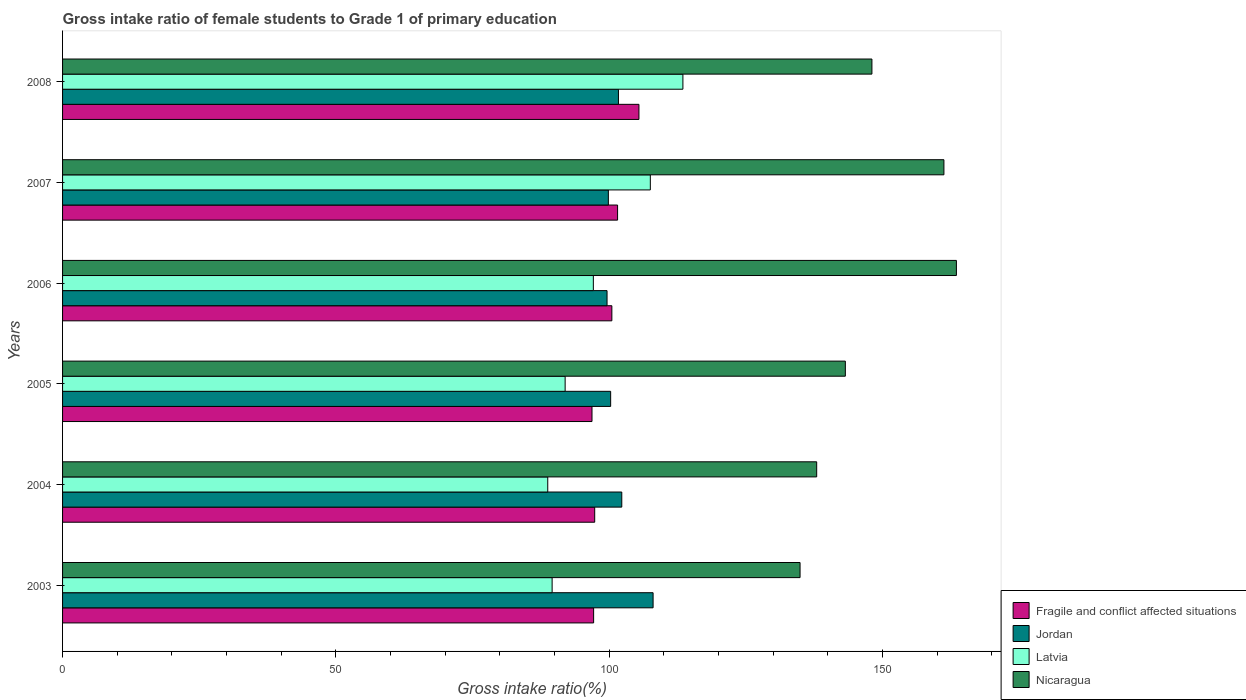How many different coloured bars are there?
Ensure brevity in your answer.  4. How many groups of bars are there?
Your answer should be very brief. 6. Are the number of bars per tick equal to the number of legend labels?
Provide a short and direct response. Yes. Are the number of bars on each tick of the Y-axis equal?
Offer a very short reply. Yes. How many bars are there on the 6th tick from the top?
Provide a succinct answer. 4. What is the gross intake ratio in Jordan in 2004?
Your response must be concise. 102.3. Across all years, what is the maximum gross intake ratio in Jordan?
Keep it short and to the point. 108.03. Across all years, what is the minimum gross intake ratio in Fragile and conflict affected situations?
Ensure brevity in your answer.  96.86. In which year was the gross intake ratio in Latvia maximum?
Offer a very short reply. 2008. In which year was the gross intake ratio in Jordan minimum?
Your response must be concise. 2006. What is the total gross intake ratio in Latvia in the graph?
Provide a short and direct response. 588.38. What is the difference between the gross intake ratio in Jordan in 2005 and that in 2006?
Provide a short and direct response. 0.66. What is the difference between the gross intake ratio in Latvia in 2006 and the gross intake ratio in Fragile and conflict affected situations in 2005?
Offer a terse response. 0.25. What is the average gross intake ratio in Latvia per year?
Make the answer very short. 98.06. In the year 2006, what is the difference between the gross intake ratio in Jordan and gross intake ratio in Fragile and conflict affected situations?
Your answer should be very brief. -0.88. In how many years, is the gross intake ratio in Jordan greater than 130 %?
Your response must be concise. 0. What is the ratio of the gross intake ratio in Latvia in 2006 to that in 2008?
Provide a short and direct response. 0.86. What is the difference between the highest and the second highest gross intake ratio in Jordan?
Ensure brevity in your answer.  5.73. What is the difference between the highest and the lowest gross intake ratio in Nicaragua?
Provide a succinct answer. 28.6. In how many years, is the gross intake ratio in Latvia greater than the average gross intake ratio in Latvia taken over all years?
Make the answer very short. 2. Is the sum of the gross intake ratio in Latvia in 2005 and 2008 greater than the maximum gross intake ratio in Nicaragua across all years?
Provide a short and direct response. Yes. Is it the case that in every year, the sum of the gross intake ratio in Nicaragua and gross intake ratio in Latvia is greater than the sum of gross intake ratio in Fragile and conflict affected situations and gross intake ratio in Jordan?
Offer a very short reply. Yes. What does the 1st bar from the top in 2003 represents?
Offer a terse response. Nicaragua. What does the 1st bar from the bottom in 2008 represents?
Provide a succinct answer. Fragile and conflict affected situations. Is it the case that in every year, the sum of the gross intake ratio in Latvia and gross intake ratio in Fragile and conflict affected situations is greater than the gross intake ratio in Jordan?
Keep it short and to the point. Yes. How many bars are there?
Keep it short and to the point. 24. How many years are there in the graph?
Ensure brevity in your answer.  6. What is the difference between two consecutive major ticks on the X-axis?
Your answer should be very brief. 50. Does the graph contain any zero values?
Give a very brief answer. No. How many legend labels are there?
Your answer should be compact. 4. What is the title of the graph?
Your answer should be very brief. Gross intake ratio of female students to Grade 1 of primary education. What is the label or title of the X-axis?
Offer a terse response. Gross intake ratio(%). What is the label or title of the Y-axis?
Make the answer very short. Years. What is the Gross intake ratio(%) in Fragile and conflict affected situations in 2003?
Offer a terse response. 97.15. What is the Gross intake ratio(%) of Jordan in 2003?
Your answer should be very brief. 108.03. What is the Gross intake ratio(%) in Latvia in 2003?
Provide a short and direct response. 89.56. What is the Gross intake ratio(%) of Nicaragua in 2003?
Offer a terse response. 134.92. What is the Gross intake ratio(%) of Fragile and conflict affected situations in 2004?
Your answer should be very brief. 97.35. What is the Gross intake ratio(%) in Jordan in 2004?
Offer a terse response. 102.3. What is the Gross intake ratio(%) of Latvia in 2004?
Your response must be concise. 88.76. What is the Gross intake ratio(%) of Nicaragua in 2004?
Your response must be concise. 137.96. What is the Gross intake ratio(%) in Fragile and conflict affected situations in 2005?
Your answer should be compact. 96.86. What is the Gross intake ratio(%) of Jordan in 2005?
Give a very brief answer. 100.27. What is the Gross intake ratio(%) in Latvia in 2005?
Your answer should be compact. 91.94. What is the Gross intake ratio(%) of Nicaragua in 2005?
Offer a terse response. 143.2. What is the Gross intake ratio(%) in Fragile and conflict affected situations in 2006?
Make the answer very short. 100.49. What is the Gross intake ratio(%) of Jordan in 2006?
Your answer should be compact. 99.61. What is the Gross intake ratio(%) in Latvia in 2006?
Offer a very short reply. 97.1. What is the Gross intake ratio(%) in Nicaragua in 2006?
Make the answer very short. 163.52. What is the Gross intake ratio(%) of Fragile and conflict affected situations in 2007?
Provide a short and direct response. 101.53. What is the Gross intake ratio(%) in Jordan in 2007?
Your response must be concise. 99.85. What is the Gross intake ratio(%) of Latvia in 2007?
Provide a short and direct response. 107.53. What is the Gross intake ratio(%) of Nicaragua in 2007?
Provide a succinct answer. 161.24. What is the Gross intake ratio(%) in Fragile and conflict affected situations in 2008?
Offer a terse response. 105.44. What is the Gross intake ratio(%) in Jordan in 2008?
Provide a short and direct response. 101.69. What is the Gross intake ratio(%) of Latvia in 2008?
Offer a very short reply. 113.48. What is the Gross intake ratio(%) in Nicaragua in 2008?
Your answer should be compact. 148.06. Across all years, what is the maximum Gross intake ratio(%) in Fragile and conflict affected situations?
Your response must be concise. 105.44. Across all years, what is the maximum Gross intake ratio(%) of Jordan?
Keep it short and to the point. 108.03. Across all years, what is the maximum Gross intake ratio(%) of Latvia?
Your answer should be compact. 113.48. Across all years, what is the maximum Gross intake ratio(%) of Nicaragua?
Offer a terse response. 163.52. Across all years, what is the minimum Gross intake ratio(%) in Fragile and conflict affected situations?
Keep it short and to the point. 96.86. Across all years, what is the minimum Gross intake ratio(%) of Jordan?
Give a very brief answer. 99.61. Across all years, what is the minimum Gross intake ratio(%) in Latvia?
Ensure brevity in your answer.  88.76. Across all years, what is the minimum Gross intake ratio(%) of Nicaragua?
Give a very brief answer. 134.92. What is the total Gross intake ratio(%) of Fragile and conflict affected situations in the graph?
Offer a terse response. 598.82. What is the total Gross intake ratio(%) in Jordan in the graph?
Offer a terse response. 611.75. What is the total Gross intake ratio(%) of Latvia in the graph?
Your answer should be very brief. 588.38. What is the total Gross intake ratio(%) in Nicaragua in the graph?
Give a very brief answer. 888.9. What is the difference between the Gross intake ratio(%) in Fragile and conflict affected situations in 2003 and that in 2004?
Make the answer very short. -0.2. What is the difference between the Gross intake ratio(%) of Jordan in 2003 and that in 2004?
Provide a succinct answer. 5.73. What is the difference between the Gross intake ratio(%) in Latvia in 2003 and that in 2004?
Your response must be concise. 0.8. What is the difference between the Gross intake ratio(%) in Nicaragua in 2003 and that in 2004?
Provide a succinct answer. -3.04. What is the difference between the Gross intake ratio(%) in Fragile and conflict affected situations in 2003 and that in 2005?
Keep it short and to the point. 0.3. What is the difference between the Gross intake ratio(%) in Jordan in 2003 and that in 2005?
Offer a very short reply. 7.76. What is the difference between the Gross intake ratio(%) of Latvia in 2003 and that in 2005?
Keep it short and to the point. -2.38. What is the difference between the Gross intake ratio(%) in Nicaragua in 2003 and that in 2005?
Give a very brief answer. -8.28. What is the difference between the Gross intake ratio(%) in Fragile and conflict affected situations in 2003 and that in 2006?
Your answer should be compact. -3.34. What is the difference between the Gross intake ratio(%) of Jordan in 2003 and that in 2006?
Give a very brief answer. 8.42. What is the difference between the Gross intake ratio(%) of Latvia in 2003 and that in 2006?
Offer a terse response. -7.54. What is the difference between the Gross intake ratio(%) of Nicaragua in 2003 and that in 2006?
Give a very brief answer. -28.6. What is the difference between the Gross intake ratio(%) in Fragile and conflict affected situations in 2003 and that in 2007?
Your answer should be compact. -4.38. What is the difference between the Gross intake ratio(%) of Jordan in 2003 and that in 2007?
Offer a very short reply. 8.18. What is the difference between the Gross intake ratio(%) in Latvia in 2003 and that in 2007?
Ensure brevity in your answer.  -17.97. What is the difference between the Gross intake ratio(%) in Nicaragua in 2003 and that in 2007?
Your answer should be compact. -26.32. What is the difference between the Gross intake ratio(%) in Fragile and conflict affected situations in 2003 and that in 2008?
Provide a succinct answer. -8.29. What is the difference between the Gross intake ratio(%) of Jordan in 2003 and that in 2008?
Ensure brevity in your answer.  6.34. What is the difference between the Gross intake ratio(%) of Latvia in 2003 and that in 2008?
Provide a short and direct response. -23.92. What is the difference between the Gross intake ratio(%) of Nicaragua in 2003 and that in 2008?
Offer a terse response. -13.15. What is the difference between the Gross intake ratio(%) of Fragile and conflict affected situations in 2004 and that in 2005?
Provide a succinct answer. 0.49. What is the difference between the Gross intake ratio(%) of Jordan in 2004 and that in 2005?
Provide a succinct answer. 2.03. What is the difference between the Gross intake ratio(%) of Latvia in 2004 and that in 2005?
Your answer should be very brief. -3.18. What is the difference between the Gross intake ratio(%) of Nicaragua in 2004 and that in 2005?
Your answer should be compact. -5.24. What is the difference between the Gross intake ratio(%) of Fragile and conflict affected situations in 2004 and that in 2006?
Keep it short and to the point. -3.14. What is the difference between the Gross intake ratio(%) in Jordan in 2004 and that in 2006?
Your response must be concise. 2.69. What is the difference between the Gross intake ratio(%) in Latvia in 2004 and that in 2006?
Make the answer very short. -8.34. What is the difference between the Gross intake ratio(%) in Nicaragua in 2004 and that in 2006?
Give a very brief answer. -25.56. What is the difference between the Gross intake ratio(%) in Fragile and conflict affected situations in 2004 and that in 2007?
Provide a short and direct response. -4.18. What is the difference between the Gross intake ratio(%) of Jordan in 2004 and that in 2007?
Make the answer very short. 2.45. What is the difference between the Gross intake ratio(%) in Latvia in 2004 and that in 2007?
Keep it short and to the point. -18.77. What is the difference between the Gross intake ratio(%) in Nicaragua in 2004 and that in 2007?
Your answer should be compact. -23.28. What is the difference between the Gross intake ratio(%) in Fragile and conflict affected situations in 2004 and that in 2008?
Give a very brief answer. -8.09. What is the difference between the Gross intake ratio(%) in Jordan in 2004 and that in 2008?
Make the answer very short. 0.61. What is the difference between the Gross intake ratio(%) in Latvia in 2004 and that in 2008?
Your answer should be very brief. -24.72. What is the difference between the Gross intake ratio(%) of Nicaragua in 2004 and that in 2008?
Give a very brief answer. -10.1. What is the difference between the Gross intake ratio(%) in Fragile and conflict affected situations in 2005 and that in 2006?
Give a very brief answer. -3.63. What is the difference between the Gross intake ratio(%) in Jordan in 2005 and that in 2006?
Offer a terse response. 0.66. What is the difference between the Gross intake ratio(%) in Latvia in 2005 and that in 2006?
Provide a succinct answer. -5.16. What is the difference between the Gross intake ratio(%) in Nicaragua in 2005 and that in 2006?
Provide a succinct answer. -20.32. What is the difference between the Gross intake ratio(%) of Fragile and conflict affected situations in 2005 and that in 2007?
Give a very brief answer. -4.68. What is the difference between the Gross intake ratio(%) of Jordan in 2005 and that in 2007?
Your answer should be compact. 0.42. What is the difference between the Gross intake ratio(%) in Latvia in 2005 and that in 2007?
Ensure brevity in your answer.  -15.59. What is the difference between the Gross intake ratio(%) in Nicaragua in 2005 and that in 2007?
Keep it short and to the point. -18.03. What is the difference between the Gross intake ratio(%) of Fragile and conflict affected situations in 2005 and that in 2008?
Ensure brevity in your answer.  -8.59. What is the difference between the Gross intake ratio(%) in Jordan in 2005 and that in 2008?
Ensure brevity in your answer.  -1.43. What is the difference between the Gross intake ratio(%) of Latvia in 2005 and that in 2008?
Offer a terse response. -21.54. What is the difference between the Gross intake ratio(%) in Nicaragua in 2005 and that in 2008?
Keep it short and to the point. -4.86. What is the difference between the Gross intake ratio(%) of Fragile and conflict affected situations in 2006 and that in 2007?
Make the answer very short. -1.04. What is the difference between the Gross intake ratio(%) of Jordan in 2006 and that in 2007?
Provide a short and direct response. -0.24. What is the difference between the Gross intake ratio(%) in Latvia in 2006 and that in 2007?
Your answer should be very brief. -10.42. What is the difference between the Gross intake ratio(%) of Nicaragua in 2006 and that in 2007?
Ensure brevity in your answer.  2.29. What is the difference between the Gross intake ratio(%) of Fragile and conflict affected situations in 2006 and that in 2008?
Give a very brief answer. -4.95. What is the difference between the Gross intake ratio(%) in Jordan in 2006 and that in 2008?
Your answer should be very brief. -2.09. What is the difference between the Gross intake ratio(%) in Latvia in 2006 and that in 2008?
Offer a terse response. -16.38. What is the difference between the Gross intake ratio(%) in Nicaragua in 2006 and that in 2008?
Ensure brevity in your answer.  15.46. What is the difference between the Gross intake ratio(%) in Fragile and conflict affected situations in 2007 and that in 2008?
Provide a short and direct response. -3.91. What is the difference between the Gross intake ratio(%) of Jordan in 2007 and that in 2008?
Offer a very short reply. -1.84. What is the difference between the Gross intake ratio(%) in Latvia in 2007 and that in 2008?
Ensure brevity in your answer.  -5.96. What is the difference between the Gross intake ratio(%) of Nicaragua in 2007 and that in 2008?
Provide a short and direct response. 13.17. What is the difference between the Gross intake ratio(%) in Fragile and conflict affected situations in 2003 and the Gross intake ratio(%) in Jordan in 2004?
Give a very brief answer. -5.15. What is the difference between the Gross intake ratio(%) in Fragile and conflict affected situations in 2003 and the Gross intake ratio(%) in Latvia in 2004?
Provide a succinct answer. 8.39. What is the difference between the Gross intake ratio(%) in Fragile and conflict affected situations in 2003 and the Gross intake ratio(%) in Nicaragua in 2004?
Offer a terse response. -40.81. What is the difference between the Gross intake ratio(%) in Jordan in 2003 and the Gross intake ratio(%) in Latvia in 2004?
Your response must be concise. 19.27. What is the difference between the Gross intake ratio(%) of Jordan in 2003 and the Gross intake ratio(%) of Nicaragua in 2004?
Your answer should be compact. -29.93. What is the difference between the Gross intake ratio(%) in Latvia in 2003 and the Gross intake ratio(%) in Nicaragua in 2004?
Keep it short and to the point. -48.4. What is the difference between the Gross intake ratio(%) in Fragile and conflict affected situations in 2003 and the Gross intake ratio(%) in Jordan in 2005?
Keep it short and to the point. -3.12. What is the difference between the Gross intake ratio(%) in Fragile and conflict affected situations in 2003 and the Gross intake ratio(%) in Latvia in 2005?
Offer a terse response. 5.21. What is the difference between the Gross intake ratio(%) of Fragile and conflict affected situations in 2003 and the Gross intake ratio(%) of Nicaragua in 2005?
Provide a succinct answer. -46.05. What is the difference between the Gross intake ratio(%) in Jordan in 2003 and the Gross intake ratio(%) in Latvia in 2005?
Your response must be concise. 16.09. What is the difference between the Gross intake ratio(%) in Jordan in 2003 and the Gross intake ratio(%) in Nicaragua in 2005?
Provide a succinct answer. -35.17. What is the difference between the Gross intake ratio(%) in Latvia in 2003 and the Gross intake ratio(%) in Nicaragua in 2005?
Your answer should be very brief. -53.64. What is the difference between the Gross intake ratio(%) in Fragile and conflict affected situations in 2003 and the Gross intake ratio(%) in Jordan in 2006?
Offer a terse response. -2.46. What is the difference between the Gross intake ratio(%) of Fragile and conflict affected situations in 2003 and the Gross intake ratio(%) of Latvia in 2006?
Offer a very short reply. 0.05. What is the difference between the Gross intake ratio(%) of Fragile and conflict affected situations in 2003 and the Gross intake ratio(%) of Nicaragua in 2006?
Make the answer very short. -66.37. What is the difference between the Gross intake ratio(%) in Jordan in 2003 and the Gross intake ratio(%) in Latvia in 2006?
Give a very brief answer. 10.93. What is the difference between the Gross intake ratio(%) in Jordan in 2003 and the Gross intake ratio(%) in Nicaragua in 2006?
Provide a succinct answer. -55.49. What is the difference between the Gross intake ratio(%) of Latvia in 2003 and the Gross intake ratio(%) of Nicaragua in 2006?
Make the answer very short. -73.96. What is the difference between the Gross intake ratio(%) in Fragile and conflict affected situations in 2003 and the Gross intake ratio(%) in Jordan in 2007?
Ensure brevity in your answer.  -2.7. What is the difference between the Gross intake ratio(%) in Fragile and conflict affected situations in 2003 and the Gross intake ratio(%) in Latvia in 2007?
Provide a succinct answer. -10.37. What is the difference between the Gross intake ratio(%) of Fragile and conflict affected situations in 2003 and the Gross intake ratio(%) of Nicaragua in 2007?
Provide a short and direct response. -64.08. What is the difference between the Gross intake ratio(%) of Jordan in 2003 and the Gross intake ratio(%) of Latvia in 2007?
Make the answer very short. 0.51. What is the difference between the Gross intake ratio(%) in Jordan in 2003 and the Gross intake ratio(%) in Nicaragua in 2007?
Keep it short and to the point. -53.2. What is the difference between the Gross intake ratio(%) in Latvia in 2003 and the Gross intake ratio(%) in Nicaragua in 2007?
Provide a short and direct response. -71.67. What is the difference between the Gross intake ratio(%) of Fragile and conflict affected situations in 2003 and the Gross intake ratio(%) of Jordan in 2008?
Offer a very short reply. -4.54. What is the difference between the Gross intake ratio(%) of Fragile and conflict affected situations in 2003 and the Gross intake ratio(%) of Latvia in 2008?
Your response must be concise. -16.33. What is the difference between the Gross intake ratio(%) in Fragile and conflict affected situations in 2003 and the Gross intake ratio(%) in Nicaragua in 2008?
Give a very brief answer. -50.91. What is the difference between the Gross intake ratio(%) of Jordan in 2003 and the Gross intake ratio(%) of Latvia in 2008?
Provide a short and direct response. -5.45. What is the difference between the Gross intake ratio(%) in Jordan in 2003 and the Gross intake ratio(%) in Nicaragua in 2008?
Ensure brevity in your answer.  -40.03. What is the difference between the Gross intake ratio(%) of Latvia in 2003 and the Gross intake ratio(%) of Nicaragua in 2008?
Your answer should be very brief. -58.5. What is the difference between the Gross intake ratio(%) of Fragile and conflict affected situations in 2004 and the Gross intake ratio(%) of Jordan in 2005?
Offer a very short reply. -2.92. What is the difference between the Gross intake ratio(%) of Fragile and conflict affected situations in 2004 and the Gross intake ratio(%) of Latvia in 2005?
Ensure brevity in your answer.  5.41. What is the difference between the Gross intake ratio(%) of Fragile and conflict affected situations in 2004 and the Gross intake ratio(%) of Nicaragua in 2005?
Ensure brevity in your answer.  -45.85. What is the difference between the Gross intake ratio(%) of Jordan in 2004 and the Gross intake ratio(%) of Latvia in 2005?
Give a very brief answer. 10.36. What is the difference between the Gross intake ratio(%) of Jordan in 2004 and the Gross intake ratio(%) of Nicaragua in 2005?
Offer a very short reply. -40.9. What is the difference between the Gross intake ratio(%) of Latvia in 2004 and the Gross intake ratio(%) of Nicaragua in 2005?
Give a very brief answer. -54.44. What is the difference between the Gross intake ratio(%) of Fragile and conflict affected situations in 2004 and the Gross intake ratio(%) of Jordan in 2006?
Make the answer very short. -2.26. What is the difference between the Gross intake ratio(%) of Fragile and conflict affected situations in 2004 and the Gross intake ratio(%) of Latvia in 2006?
Make the answer very short. 0.25. What is the difference between the Gross intake ratio(%) in Fragile and conflict affected situations in 2004 and the Gross intake ratio(%) in Nicaragua in 2006?
Keep it short and to the point. -66.17. What is the difference between the Gross intake ratio(%) of Jordan in 2004 and the Gross intake ratio(%) of Latvia in 2006?
Provide a short and direct response. 5.2. What is the difference between the Gross intake ratio(%) in Jordan in 2004 and the Gross intake ratio(%) in Nicaragua in 2006?
Make the answer very short. -61.22. What is the difference between the Gross intake ratio(%) in Latvia in 2004 and the Gross intake ratio(%) in Nicaragua in 2006?
Make the answer very short. -74.76. What is the difference between the Gross intake ratio(%) in Fragile and conflict affected situations in 2004 and the Gross intake ratio(%) in Jordan in 2007?
Your response must be concise. -2.5. What is the difference between the Gross intake ratio(%) of Fragile and conflict affected situations in 2004 and the Gross intake ratio(%) of Latvia in 2007?
Ensure brevity in your answer.  -10.18. What is the difference between the Gross intake ratio(%) of Fragile and conflict affected situations in 2004 and the Gross intake ratio(%) of Nicaragua in 2007?
Your response must be concise. -63.89. What is the difference between the Gross intake ratio(%) in Jordan in 2004 and the Gross intake ratio(%) in Latvia in 2007?
Keep it short and to the point. -5.22. What is the difference between the Gross intake ratio(%) in Jordan in 2004 and the Gross intake ratio(%) in Nicaragua in 2007?
Provide a short and direct response. -58.93. What is the difference between the Gross intake ratio(%) in Latvia in 2004 and the Gross intake ratio(%) in Nicaragua in 2007?
Provide a short and direct response. -72.48. What is the difference between the Gross intake ratio(%) of Fragile and conflict affected situations in 2004 and the Gross intake ratio(%) of Jordan in 2008?
Make the answer very short. -4.34. What is the difference between the Gross intake ratio(%) of Fragile and conflict affected situations in 2004 and the Gross intake ratio(%) of Latvia in 2008?
Provide a succinct answer. -16.13. What is the difference between the Gross intake ratio(%) of Fragile and conflict affected situations in 2004 and the Gross intake ratio(%) of Nicaragua in 2008?
Ensure brevity in your answer.  -50.71. What is the difference between the Gross intake ratio(%) in Jordan in 2004 and the Gross intake ratio(%) in Latvia in 2008?
Your answer should be compact. -11.18. What is the difference between the Gross intake ratio(%) of Jordan in 2004 and the Gross intake ratio(%) of Nicaragua in 2008?
Give a very brief answer. -45.76. What is the difference between the Gross intake ratio(%) of Latvia in 2004 and the Gross intake ratio(%) of Nicaragua in 2008?
Ensure brevity in your answer.  -59.3. What is the difference between the Gross intake ratio(%) of Fragile and conflict affected situations in 2005 and the Gross intake ratio(%) of Jordan in 2006?
Keep it short and to the point. -2.75. What is the difference between the Gross intake ratio(%) of Fragile and conflict affected situations in 2005 and the Gross intake ratio(%) of Latvia in 2006?
Make the answer very short. -0.25. What is the difference between the Gross intake ratio(%) in Fragile and conflict affected situations in 2005 and the Gross intake ratio(%) in Nicaragua in 2006?
Keep it short and to the point. -66.67. What is the difference between the Gross intake ratio(%) in Jordan in 2005 and the Gross intake ratio(%) in Latvia in 2006?
Your answer should be very brief. 3.17. What is the difference between the Gross intake ratio(%) of Jordan in 2005 and the Gross intake ratio(%) of Nicaragua in 2006?
Provide a short and direct response. -63.25. What is the difference between the Gross intake ratio(%) of Latvia in 2005 and the Gross intake ratio(%) of Nicaragua in 2006?
Your answer should be compact. -71.58. What is the difference between the Gross intake ratio(%) of Fragile and conflict affected situations in 2005 and the Gross intake ratio(%) of Jordan in 2007?
Offer a very short reply. -2.99. What is the difference between the Gross intake ratio(%) in Fragile and conflict affected situations in 2005 and the Gross intake ratio(%) in Latvia in 2007?
Your answer should be compact. -10.67. What is the difference between the Gross intake ratio(%) of Fragile and conflict affected situations in 2005 and the Gross intake ratio(%) of Nicaragua in 2007?
Your response must be concise. -64.38. What is the difference between the Gross intake ratio(%) of Jordan in 2005 and the Gross intake ratio(%) of Latvia in 2007?
Provide a short and direct response. -7.26. What is the difference between the Gross intake ratio(%) of Jordan in 2005 and the Gross intake ratio(%) of Nicaragua in 2007?
Your answer should be compact. -60.97. What is the difference between the Gross intake ratio(%) of Latvia in 2005 and the Gross intake ratio(%) of Nicaragua in 2007?
Make the answer very short. -69.29. What is the difference between the Gross intake ratio(%) of Fragile and conflict affected situations in 2005 and the Gross intake ratio(%) of Jordan in 2008?
Offer a terse response. -4.84. What is the difference between the Gross intake ratio(%) of Fragile and conflict affected situations in 2005 and the Gross intake ratio(%) of Latvia in 2008?
Offer a terse response. -16.63. What is the difference between the Gross intake ratio(%) of Fragile and conflict affected situations in 2005 and the Gross intake ratio(%) of Nicaragua in 2008?
Provide a succinct answer. -51.21. What is the difference between the Gross intake ratio(%) of Jordan in 2005 and the Gross intake ratio(%) of Latvia in 2008?
Offer a very short reply. -13.22. What is the difference between the Gross intake ratio(%) in Jordan in 2005 and the Gross intake ratio(%) in Nicaragua in 2008?
Make the answer very short. -47.8. What is the difference between the Gross intake ratio(%) in Latvia in 2005 and the Gross intake ratio(%) in Nicaragua in 2008?
Your response must be concise. -56.12. What is the difference between the Gross intake ratio(%) in Fragile and conflict affected situations in 2006 and the Gross intake ratio(%) in Jordan in 2007?
Your response must be concise. 0.64. What is the difference between the Gross intake ratio(%) in Fragile and conflict affected situations in 2006 and the Gross intake ratio(%) in Latvia in 2007?
Your answer should be compact. -7.04. What is the difference between the Gross intake ratio(%) in Fragile and conflict affected situations in 2006 and the Gross intake ratio(%) in Nicaragua in 2007?
Make the answer very short. -60.75. What is the difference between the Gross intake ratio(%) in Jordan in 2006 and the Gross intake ratio(%) in Latvia in 2007?
Keep it short and to the point. -7.92. What is the difference between the Gross intake ratio(%) in Jordan in 2006 and the Gross intake ratio(%) in Nicaragua in 2007?
Offer a very short reply. -61.63. What is the difference between the Gross intake ratio(%) in Latvia in 2006 and the Gross intake ratio(%) in Nicaragua in 2007?
Give a very brief answer. -64.13. What is the difference between the Gross intake ratio(%) of Fragile and conflict affected situations in 2006 and the Gross intake ratio(%) of Jordan in 2008?
Offer a very short reply. -1.2. What is the difference between the Gross intake ratio(%) in Fragile and conflict affected situations in 2006 and the Gross intake ratio(%) in Latvia in 2008?
Make the answer very short. -13. What is the difference between the Gross intake ratio(%) in Fragile and conflict affected situations in 2006 and the Gross intake ratio(%) in Nicaragua in 2008?
Give a very brief answer. -47.57. What is the difference between the Gross intake ratio(%) of Jordan in 2006 and the Gross intake ratio(%) of Latvia in 2008?
Provide a short and direct response. -13.88. What is the difference between the Gross intake ratio(%) of Jordan in 2006 and the Gross intake ratio(%) of Nicaragua in 2008?
Make the answer very short. -48.46. What is the difference between the Gross intake ratio(%) of Latvia in 2006 and the Gross intake ratio(%) of Nicaragua in 2008?
Keep it short and to the point. -50.96. What is the difference between the Gross intake ratio(%) in Fragile and conflict affected situations in 2007 and the Gross intake ratio(%) in Jordan in 2008?
Your response must be concise. -0.16. What is the difference between the Gross intake ratio(%) of Fragile and conflict affected situations in 2007 and the Gross intake ratio(%) of Latvia in 2008?
Your answer should be compact. -11.95. What is the difference between the Gross intake ratio(%) in Fragile and conflict affected situations in 2007 and the Gross intake ratio(%) in Nicaragua in 2008?
Provide a succinct answer. -46.53. What is the difference between the Gross intake ratio(%) of Jordan in 2007 and the Gross intake ratio(%) of Latvia in 2008?
Keep it short and to the point. -13.64. What is the difference between the Gross intake ratio(%) in Jordan in 2007 and the Gross intake ratio(%) in Nicaragua in 2008?
Provide a succinct answer. -48.22. What is the difference between the Gross intake ratio(%) in Latvia in 2007 and the Gross intake ratio(%) in Nicaragua in 2008?
Provide a short and direct response. -40.54. What is the average Gross intake ratio(%) in Fragile and conflict affected situations per year?
Provide a succinct answer. 99.8. What is the average Gross intake ratio(%) of Jordan per year?
Offer a terse response. 101.96. What is the average Gross intake ratio(%) in Latvia per year?
Your response must be concise. 98.06. What is the average Gross intake ratio(%) in Nicaragua per year?
Ensure brevity in your answer.  148.15. In the year 2003, what is the difference between the Gross intake ratio(%) of Fragile and conflict affected situations and Gross intake ratio(%) of Jordan?
Ensure brevity in your answer.  -10.88. In the year 2003, what is the difference between the Gross intake ratio(%) of Fragile and conflict affected situations and Gross intake ratio(%) of Latvia?
Provide a short and direct response. 7.59. In the year 2003, what is the difference between the Gross intake ratio(%) in Fragile and conflict affected situations and Gross intake ratio(%) in Nicaragua?
Make the answer very short. -37.77. In the year 2003, what is the difference between the Gross intake ratio(%) in Jordan and Gross intake ratio(%) in Latvia?
Offer a terse response. 18.47. In the year 2003, what is the difference between the Gross intake ratio(%) in Jordan and Gross intake ratio(%) in Nicaragua?
Ensure brevity in your answer.  -26.89. In the year 2003, what is the difference between the Gross intake ratio(%) in Latvia and Gross intake ratio(%) in Nicaragua?
Your answer should be very brief. -45.36. In the year 2004, what is the difference between the Gross intake ratio(%) of Fragile and conflict affected situations and Gross intake ratio(%) of Jordan?
Your response must be concise. -4.95. In the year 2004, what is the difference between the Gross intake ratio(%) of Fragile and conflict affected situations and Gross intake ratio(%) of Latvia?
Your answer should be very brief. 8.59. In the year 2004, what is the difference between the Gross intake ratio(%) of Fragile and conflict affected situations and Gross intake ratio(%) of Nicaragua?
Offer a terse response. -40.61. In the year 2004, what is the difference between the Gross intake ratio(%) of Jordan and Gross intake ratio(%) of Latvia?
Provide a short and direct response. 13.54. In the year 2004, what is the difference between the Gross intake ratio(%) of Jordan and Gross intake ratio(%) of Nicaragua?
Provide a short and direct response. -35.66. In the year 2004, what is the difference between the Gross intake ratio(%) in Latvia and Gross intake ratio(%) in Nicaragua?
Offer a terse response. -49.2. In the year 2005, what is the difference between the Gross intake ratio(%) of Fragile and conflict affected situations and Gross intake ratio(%) of Jordan?
Your answer should be very brief. -3.41. In the year 2005, what is the difference between the Gross intake ratio(%) of Fragile and conflict affected situations and Gross intake ratio(%) of Latvia?
Your response must be concise. 4.91. In the year 2005, what is the difference between the Gross intake ratio(%) of Fragile and conflict affected situations and Gross intake ratio(%) of Nicaragua?
Make the answer very short. -46.35. In the year 2005, what is the difference between the Gross intake ratio(%) of Jordan and Gross intake ratio(%) of Latvia?
Offer a very short reply. 8.33. In the year 2005, what is the difference between the Gross intake ratio(%) of Jordan and Gross intake ratio(%) of Nicaragua?
Give a very brief answer. -42.93. In the year 2005, what is the difference between the Gross intake ratio(%) of Latvia and Gross intake ratio(%) of Nicaragua?
Give a very brief answer. -51.26. In the year 2006, what is the difference between the Gross intake ratio(%) of Fragile and conflict affected situations and Gross intake ratio(%) of Jordan?
Your answer should be compact. 0.88. In the year 2006, what is the difference between the Gross intake ratio(%) in Fragile and conflict affected situations and Gross intake ratio(%) in Latvia?
Keep it short and to the point. 3.39. In the year 2006, what is the difference between the Gross intake ratio(%) in Fragile and conflict affected situations and Gross intake ratio(%) in Nicaragua?
Make the answer very short. -63.03. In the year 2006, what is the difference between the Gross intake ratio(%) of Jordan and Gross intake ratio(%) of Latvia?
Give a very brief answer. 2.51. In the year 2006, what is the difference between the Gross intake ratio(%) of Jordan and Gross intake ratio(%) of Nicaragua?
Ensure brevity in your answer.  -63.91. In the year 2006, what is the difference between the Gross intake ratio(%) of Latvia and Gross intake ratio(%) of Nicaragua?
Offer a very short reply. -66.42. In the year 2007, what is the difference between the Gross intake ratio(%) of Fragile and conflict affected situations and Gross intake ratio(%) of Jordan?
Your answer should be compact. 1.68. In the year 2007, what is the difference between the Gross intake ratio(%) in Fragile and conflict affected situations and Gross intake ratio(%) in Latvia?
Your answer should be compact. -5.99. In the year 2007, what is the difference between the Gross intake ratio(%) in Fragile and conflict affected situations and Gross intake ratio(%) in Nicaragua?
Ensure brevity in your answer.  -59.7. In the year 2007, what is the difference between the Gross intake ratio(%) of Jordan and Gross intake ratio(%) of Latvia?
Your answer should be compact. -7.68. In the year 2007, what is the difference between the Gross intake ratio(%) of Jordan and Gross intake ratio(%) of Nicaragua?
Offer a very short reply. -61.39. In the year 2007, what is the difference between the Gross intake ratio(%) in Latvia and Gross intake ratio(%) in Nicaragua?
Give a very brief answer. -53.71. In the year 2008, what is the difference between the Gross intake ratio(%) in Fragile and conflict affected situations and Gross intake ratio(%) in Jordan?
Make the answer very short. 3.75. In the year 2008, what is the difference between the Gross intake ratio(%) of Fragile and conflict affected situations and Gross intake ratio(%) of Latvia?
Offer a very short reply. -8.04. In the year 2008, what is the difference between the Gross intake ratio(%) of Fragile and conflict affected situations and Gross intake ratio(%) of Nicaragua?
Give a very brief answer. -42.62. In the year 2008, what is the difference between the Gross intake ratio(%) of Jordan and Gross intake ratio(%) of Latvia?
Ensure brevity in your answer.  -11.79. In the year 2008, what is the difference between the Gross intake ratio(%) in Jordan and Gross intake ratio(%) in Nicaragua?
Your response must be concise. -46.37. In the year 2008, what is the difference between the Gross intake ratio(%) of Latvia and Gross intake ratio(%) of Nicaragua?
Keep it short and to the point. -34.58. What is the ratio of the Gross intake ratio(%) in Fragile and conflict affected situations in 2003 to that in 2004?
Provide a short and direct response. 1. What is the ratio of the Gross intake ratio(%) in Jordan in 2003 to that in 2004?
Make the answer very short. 1.06. What is the ratio of the Gross intake ratio(%) of Latvia in 2003 to that in 2004?
Your answer should be very brief. 1.01. What is the ratio of the Gross intake ratio(%) in Fragile and conflict affected situations in 2003 to that in 2005?
Offer a terse response. 1. What is the ratio of the Gross intake ratio(%) in Jordan in 2003 to that in 2005?
Ensure brevity in your answer.  1.08. What is the ratio of the Gross intake ratio(%) in Latvia in 2003 to that in 2005?
Offer a terse response. 0.97. What is the ratio of the Gross intake ratio(%) in Nicaragua in 2003 to that in 2005?
Offer a very short reply. 0.94. What is the ratio of the Gross intake ratio(%) of Fragile and conflict affected situations in 2003 to that in 2006?
Offer a terse response. 0.97. What is the ratio of the Gross intake ratio(%) of Jordan in 2003 to that in 2006?
Your answer should be compact. 1.08. What is the ratio of the Gross intake ratio(%) in Latvia in 2003 to that in 2006?
Offer a very short reply. 0.92. What is the ratio of the Gross intake ratio(%) of Nicaragua in 2003 to that in 2006?
Make the answer very short. 0.83. What is the ratio of the Gross intake ratio(%) of Fragile and conflict affected situations in 2003 to that in 2007?
Make the answer very short. 0.96. What is the ratio of the Gross intake ratio(%) of Jordan in 2003 to that in 2007?
Provide a short and direct response. 1.08. What is the ratio of the Gross intake ratio(%) of Latvia in 2003 to that in 2007?
Provide a short and direct response. 0.83. What is the ratio of the Gross intake ratio(%) in Nicaragua in 2003 to that in 2007?
Give a very brief answer. 0.84. What is the ratio of the Gross intake ratio(%) in Fragile and conflict affected situations in 2003 to that in 2008?
Ensure brevity in your answer.  0.92. What is the ratio of the Gross intake ratio(%) of Jordan in 2003 to that in 2008?
Offer a very short reply. 1.06. What is the ratio of the Gross intake ratio(%) of Latvia in 2003 to that in 2008?
Your answer should be very brief. 0.79. What is the ratio of the Gross intake ratio(%) in Nicaragua in 2003 to that in 2008?
Offer a very short reply. 0.91. What is the ratio of the Gross intake ratio(%) of Jordan in 2004 to that in 2005?
Make the answer very short. 1.02. What is the ratio of the Gross intake ratio(%) of Latvia in 2004 to that in 2005?
Provide a succinct answer. 0.97. What is the ratio of the Gross intake ratio(%) of Nicaragua in 2004 to that in 2005?
Ensure brevity in your answer.  0.96. What is the ratio of the Gross intake ratio(%) of Fragile and conflict affected situations in 2004 to that in 2006?
Make the answer very short. 0.97. What is the ratio of the Gross intake ratio(%) of Jordan in 2004 to that in 2006?
Provide a succinct answer. 1.03. What is the ratio of the Gross intake ratio(%) in Latvia in 2004 to that in 2006?
Provide a succinct answer. 0.91. What is the ratio of the Gross intake ratio(%) in Nicaragua in 2004 to that in 2006?
Your answer should be compact. 0.84. What is the ratio of the Gross intake ratio(%) in Fragile and conflict affected situations in 2004 to that in 2007?
Keep it short and to the point. 0.96. What is the ratio of the Gross intake ratio(%) of Jordan in 2004 to that in 2007?
Provide a short and direct response. 1.02. What is the ratio of the Gross intake ratio(%) in Latvia in 2004 to that in 2007?
Provide a succinct answer. 0.83. What is the ratio of the Gross intake ratio(%) in Nicaragua in 2004 to that in 2007?
Offer a very short reply. 0.86. What is the ratio of the Gross intake ratio(%) of Fragile and conflict affected situations in 2004 to that in 2008?
Your response must be concise. 0.92. What is the ratio of the Gross intake ratio(%) of Latvia in 2004 to that in 2008?
Provide a short and direct response. 0.78. What is the ratio of the Gross intake ratio(%) in Nicaragua in 2004 to that in 2008?
Offer a terse response. 0.93. What is the ratio of the Gross intake ratio(%) in Fragile and conflict affected situations in 2005 to that in 2006?
Your answer should be very brief. 0.96. What is the ratio of the Gross intake ratio(%) in Jordan in 2005 to that in 2006?
Offer a terse response. 1.01. What is the ratio of the Gross intake ratio(%) of Latvia in 2005 to that in 2006?
Offer a very short reply. 0.95. What is the ratio of the Gross intake ratio(%) of Nicaragua in 2005 to that in 2006?
Your answer should be compact. 0.88. What is the ratio of the Gross intake ratio(%) in Fragile and conflict affected situations in 2005 to that in 2007?
Provide a succinct answer. 0.95. What is the ratio of the Gross intake ratio(%) of Latvia in 2005 to that in 2007?
Provide a short and direct response. 0.86. What is the ratio of the Gross intake ratio(%) in Nicaragua in 2005 to that in 2007?
Ensure brevity in your answer.  0.89. What is the ratio of the Gross intake ratio(%) in Fragile and conflict affected situations in 2005 to that in 2008?
Offer a terse response. 0.92. What is the ratio of the Gross intake ratio(%) of Jordan in 2005 to that in 2008?
Your response must be concise. 0.99. What is the ratio of the Gross intake ratio(%) of Latvia in 2005 to that in 2008?
Make the answer very short. 0.81. What is the ratio of the Gross intake ratio(%) of Nicaragua in 2005 to that in 2008?
Keep it short and to the point. 0.97. What is the ratio of the Gross intake ratio(%) in Jordan in 2006 to that in 2007?
Your answer should be very brief. 1. What is the ratio of the Gross intake ratio(%) in Latvia in 2006 to that in 2007?
Ensure brevity in your answer.  0.9. What is the ratio of the Gross intake ratio(%) of Nicaragua in 2006 to that in 2007?
Make the answer very short. 1.01. What is the ratio of the Gross intake ratio(%) in Fragile and conflict affected situations in 2006 to that in 2008?
Keep it short and to the point. 0.95. What is the ratio of the Gross intake ratio(%) of Jordan in 2006 to that in 2008?
Make the answer very short. 0.98. What is the ratio of the Gross intake ratio(%) of Latvia in 2006 to that in 2008?
Provide a short and direct response. 0.86. What is the ratio of the Gross intake ratio(%) in Nicaragua in 2006 to that in 2008?
Keep it short and to the point. 1.1. What is the ratio of the Gross intake ratio(%) in Fragile and conflict affected situations in 2007 to that in 2008?
Your response must be concise. 0.96. What is the ratio of the Gross intake ratio(%) in Jordan in 2007 to that in 2008?
Provide a short and direct response. 0.98. What is the ratio of the Gross intake ratio(%) of Latvia in 2007 to that in 2008?
Provide a short and direct response. 0.95. What is the ratio of the Gross intake ratio(%) in Nicaragua in 2007 to that in 2008?
Offer a very short reply. 1.09. What is the difference between the highest and the second highest Gross intake ratio(%) in Fragile and conflict affected situations?
Your answer should be very brief. 3.91. What is the difference between the highest and the second highest Gross intake ratio(%) of Jordan?
Your answer should be compact. 5.73. What is the difference between the highest and the second highest Gross intake ratio(%) of Latvia?
Make the answer very short. 5.96. What is the difference between the highest and the second highest Gross intake ratio(%) of Nicaragua?
Provide a short and direct response. 2.29. What is the difference between the highest and the lowest Gross intake ratio(%) of Fragile and conflict affected situations?
Provide a succinct answer. 8.59. What is the difference between the highest and the lowest Gross intake ratio(%) of Jordan?
Your answer should be very brief. 8.42. What is the difference between the highest and the lowest Gross intake ratio(%) of Latvia?
Keep it short and to the point. 24.72. What is the difference between the highest and the lowest Gross intake ratio(%) of Nicaragua?
Your response must be concise. 28.6. 